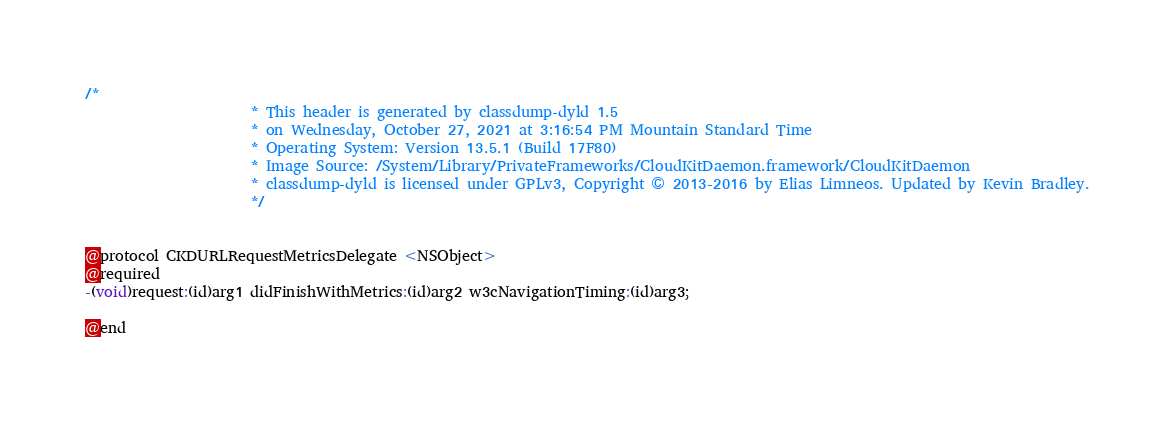Convert code to text. <code><loc_0><loc_0><loc_500><loc_500><_C_>/*
                       * This header is generated by classdump-dyld 1.5
                       * on Wednesday, October 27, 2021 at 3:16:54 PM Mountain Standard Time
                       * Operating System: Version 13.5.1 (Build 17F80)
                       * Image Source: /System/Library/PrivateFrameworks/CloudKitDaemon.framework/CloudKitDaemon
                       * classdump-dyld is licensed under GPLv3, Copyright © 2013-2016 by Elias Limneos. Updated by Kevin Bradley.
                       */


@protocol CKDURLRequestMetricsDelegate <NSObject>
@required
-(void)request:(id)arg1 didFinishWithMetrics:(id)arg2 w3cNavigationTiming:(id)arg3;

@end

</code> 